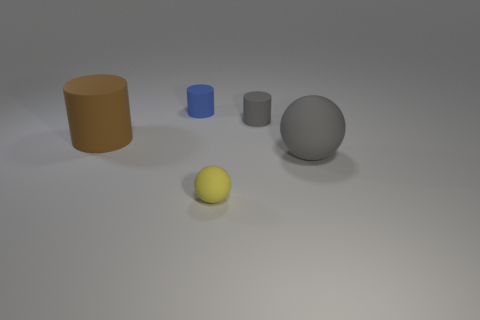Add 2 tiny gray matte cylinders. How many objects exist? 7 Subtract all balls. How many objects are left? 3 Add 4 cylinders. How many cylinders are left? 7 Add 4 large yellow blocks. How many large yellow blocks exist? 4 Subtract 0 blue balls. How many objects are left? 5 Subtract all big gray rubber objects. Subtract all large cyan cubes. How many objects are left? 4 